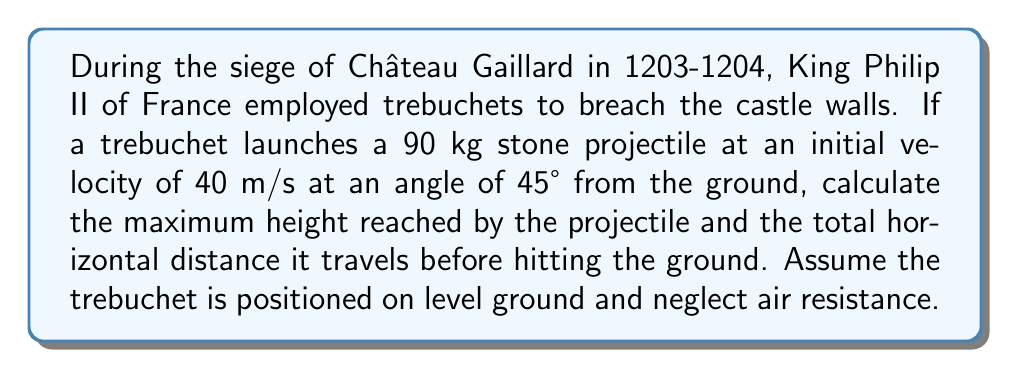Give your solution to this math problem. To solve this problem, we'll use the equations of motion for projectile motion. Let's break it down step by step:

1. Given information:
   - Initial velocity, $v_0 = 40$ m/s
   - Launch angle, $\theta = 45°$
   - Mass of projectile, $m = 90$ kg (not needed for trajectory calculations)
   - Acceleration due to gravity, $g = 9.8$ m/s²

2. Calculate the initial vertical and horizontal components of velocity:
   $v_{0x} = v_0 \cos{\theta} = 40 \cos{45°} = 40 \cdot \frac{\sqrt{2}}{2} \approx 28.28$ m/s
   $v_{0y} = v_0 \sin{\theta} = 40 \sin{45°} = 40 \cdot \frac{\sqrt{2}}{2} \approx 28.28$ m/s

3. Calculate the time to reach maximum height:
   At the highest point, vertical velocity is zero.
   $v_y = v_{0y} - gt = 0$
   $t = \frac{v_{0y}}{g} = \frac{28.28}{9.8} \approx 2.89$ seconds

4. Calculate the maximum height:
   Using the equation $y = v_{0y}t - \frac{1}{2}gt^2$
   $y_{max} = 28.28 \cdot 2.89 - \frac{1}{2} \cdot 9.8 \cdot 2.89^2 \approx 40.82$ meters

5. Calculate the total time of flight:
   The total time is twice the time to reach maximum height.
   $t_{total} = 2 \cdot 2.89 = 5.78$ seconds

6. Calculate the total horizontal distance:
   $x = v_{0x} \cdot t_{total} = 28.28 \cdot 5.78 \approx 163.46$ meters

[asy]
import graph;
size(200,150);
real f(real x) {return -0.00367*x^2 + 0.6*x;}
draw(graph(f,0,163.46));
draw((0,0)--(163.46,0),arrow=Arrow(TeXHead));
draw((0,0)--(0,50),arrow=Arrow(TeXHead));
label("x (m)",(163.46,0),SE);
label("y (m)",(0,50),NW);
label("Trajectory",(80,30),N);
dot((81.73,40.82));
label("Max Height",(81.73,40.82),NE);
[/asy]
Answer: The maximum height reached by the projectile is approximately 40.82 meters, and the total horizontal distance traveled is approximately 163.46 meters. 